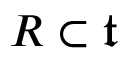Convert formula to latex. <formula><loc_0><loc_0><loc_500><loc_500>R \subset { \mathfrak { t } }</formula> 